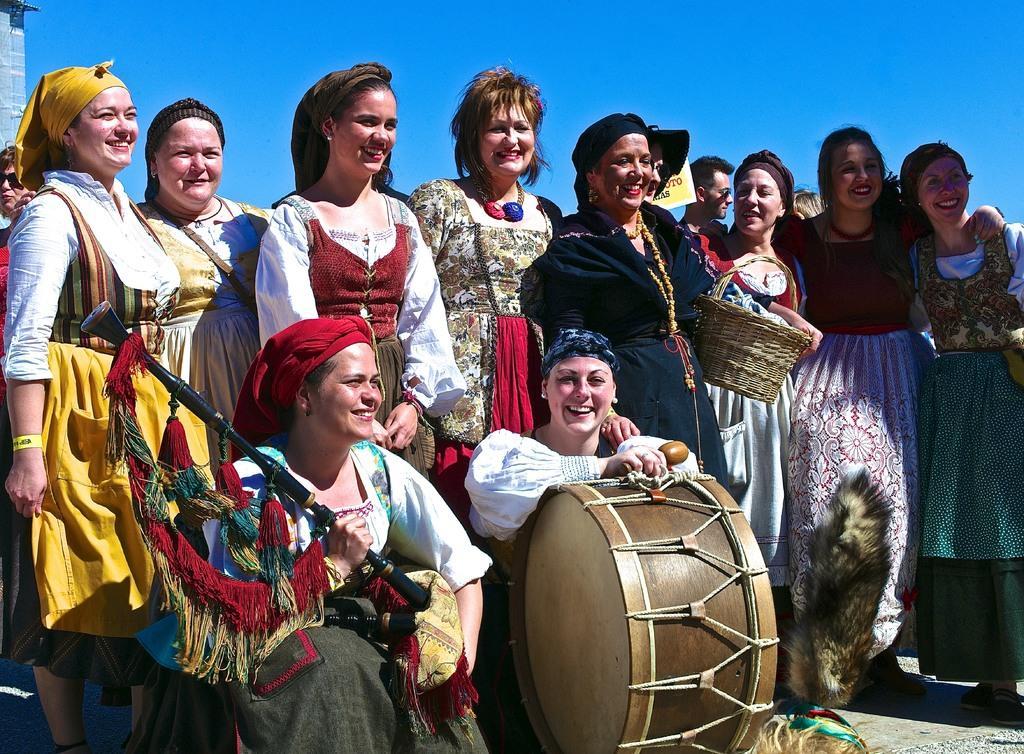Describe this image in one or two sentences. In this image i can see few women standing and two women sitting in front of them holding musical instruments in their hands. In the background i can see a building, a person and the sky. 